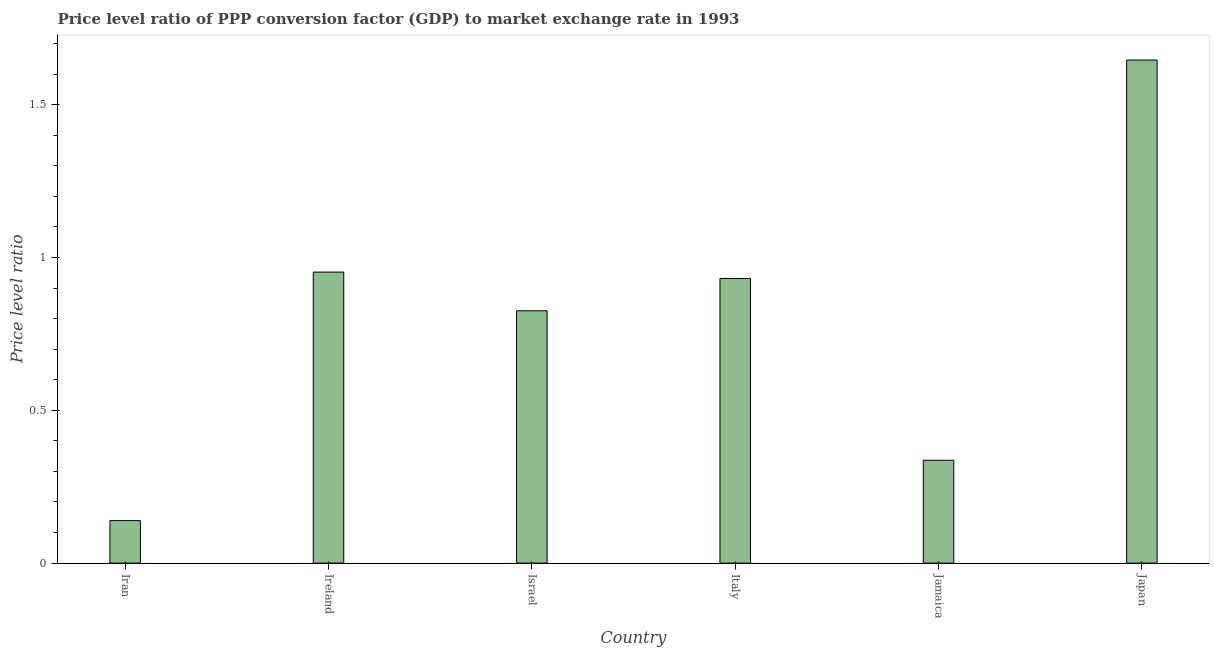Does the graph contain any zero values?
Make the answer very short. No. What is the title of the graph?
Make the answer very short. Price level ratio of PPP conversion factor (GDP) to market exchange rate in 1993. What is the label or title of the Y-axis?
Ensure brevity in your answer.  Price level ratio. What is the price level ratio in Ireland?
Offer a very short reply. 0.95. Across all countries, what is the maximum price level ratio?
Offer a very short reply. 1.65. Across all countries, what is the minimum price level ratio?
Your answer should be very brief. 0.14. In which country was the price level ratio maximum?
Provide a short and direct response. Japan. In which country was the price level ratio minimum?
Offer a very short reply. Iran. What is the sum of the price level ratio?
Keep it short and to the point. 4.83. What is the difference between the price level ratio in Jamaica and Japan?
Give a very brief answer. -1.31. What is the average price level ratio per country?
Your response must be concise. 0.81. What is the median price level ratio?
Make the answer very short. 0.88. What is the ratio of the price level ratio in Ireland to that in Jamaica?
Offer a very short reply. 2.83. Is the price level ratio in Iran less than that in Italy?
Your answer should be very brief. Yes. Is the difference between the price level ratio in Ireland and Jamaica greater than the difference between any two countries?
Keep it short and to the point. No. What is the difference between the highest and the second highest price level ratio?
Keep it short and to the point. 0.69. What is the difference between the highest and the lowest price level ratio?
Give a very brief answer. 1.51. How many bars are there?
Offer a very short reply. 6. Are all the bars in the graph horizontal?
Offer a terse response. No. How many countries are there in the graph?
Offer a very short reply. 6. Are the values on the major ticks of Y-axis written in scientific E-notation?
Provide a short and direct response. No. What is the Price level ratio in Iran?
Offer a terse response. 0.14. What is the Price level ratio in Ireland?
Ensure brevity in your answer.  0.95. What is the Price level ratio in Israel?
Ensure brevity in your answer.  0.83. What is the Price level ratio in Italy?
Offer a terse response. 0.93. What is the Price level ratio of Jamaica?
Offer a terse response. 0.34. What is the Price level ratio of Japan?
Ensure brevity in your answer.  1.65. What is the difference between the Price level ratio in Iran and Ireland?
Provide a succinct answer. -0.81. What is the difference between the Price level ratio in Iran and Israel?
Ensure brevity in your answer.  -0.69. What is the difference between the Price level ratio in Iran and Italy?
Ensure brevity in your answer.  -0.79. What is the difference between the Price level ratio in Iran and Jamaica?
Offer a terse response. -0.2. What is the difference between the Price level ratio in Iran and Japan?
Your response must be concise. -1.51. What is the difference between the Price level ratio in Ireland and Israel?
Ensure brevity in your answer.  0.13. What is the difference between the Price level ratio in Ireland and Italy?
Give a very brief answer. 0.02. What is the difference between the Price level ratio in Ireland and Jamaica?
Offer a very short reply. 0.62. What is the difference between the Price level ratio in Ireland and Japan?
Your answer should be very brief. -0.69. What is the difference between the Price level ratio in Israel and Italy?
Make the answer very short. -0.11. What is the difference between the Price level ratio in Israel and Jamaica?
Offer a very short reply. 0.49. What is the difference between the Price level ratio in Israel and Japan?
Make the answer very short. -0.82. What is the difference between the Price level ratio in Italy and Jamaica?
Your answer should be compact. 0.59. What is the difference between the Price level ratio in Italy and Japan?
Keep it short and to the point. -0.71. What is the difference between the Price level ratio in Jamaica and Japan?
Your answer should be very brief. -1.31. What is the ratio of the Price level ratio in Iran to that in Ireland?
Your answer should be compact. 0.15. What is the ratio of the Price level ratio in Iran to that in Israel?
Keep it short and to the point. 0.17. What is the ratio of the Price level ratio in Iran to that in Italy?
Ensure brevity in your answer.  0.15. What is the ratio of the Price level ratio in Iran to that in Jamaica?
Provide a succinct answer. 0.41. What is the ratio of the Price level ratio in Iran to that in Japan?
Your answer should be very brief. 0.08. What is the ratio of the Price level ratio in Ireland to that in Israel?
Provide a succinct answer. 1.15. What is the ratio of the Price level ratio in Ireland to that in Italy?
Keep it short and to the point. 1.02. What is the ratio of the Price level ratio in Ireland to that in Jamaica?
Ensure brevity in your answer.  2.83. What is the ratio of the Price level ratio in Ireland to that in Japan?
Ensure brevity in your answer.  0.58. What is the ratio of the Price level ratio in Israel to that in Italy?
Your answer should be compact. 0.89. What is the ratio of the Price level ratio in Israel to that in Jamaica?
Keep it short and to the point. 2.45. What is the ratio of the Price level ratio in Israel to that in Japan?
Your answer should be very brief. 0.5. What is the ratio of the Price level ratio in Italy to that in Jamaica?
Make the answer very short. 2.77. What is the ratio of the Price level ratio in Italy to that in Japan?
Ensure brevity in your answer.  0.57. What is the ratio of the Price level ratio in Jamaica to that in Japan?
Offer a terse response. 0.2. 